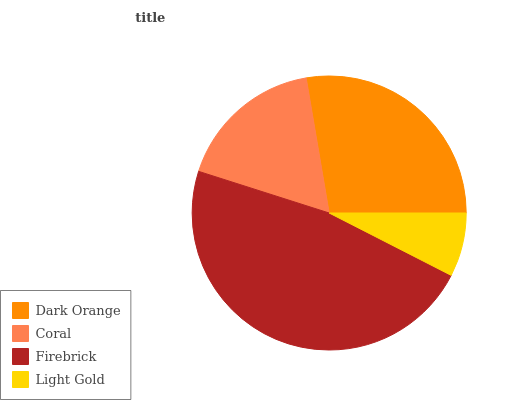Is Light Gold the minimum?
Answer yes or no. Yes. Is Firebrick the maximum?
Answer yes or no. Yes. Is Coral the minimum?
Answer yes or no. No. Is Coral the maximum?
Answer yes or no. No. Is Dark Orange greater than Coral?
Answer yes or no. Yes. Is Coral less than Dark Orange?
Answer yes or no. Yes. Is Coral greater than Dark Orange?
Answer yes or no. No. Is Dark Orange less than Coral?
Answer yes or no. No. Is Dark Orange the high median?
Answer yes or no. Yes. Is Coral the low median?
Answer yes or no. Yes. Is Coral the high median?
Answer yes or no. No. Is Light Gold the low median?
Answer yes or no. No. 